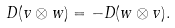<formula> <loc_0><loc_0><loc_500><loc_500>D ( v \otimes w ) = - D ( w \otimes v ) .</formula> 